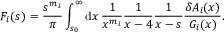<formula> <loc_0><loc_0><loc_500><loc_500>F _ { i } ( s ) = { \frac { s ^ { m _ { i } } } { \pi } } \int _ { s _ { 0 } } ^ { \infty } d x \, { \frac { 1 } { x ^ { m _ { i } } } } { \frac { 1 } { x - 4 } } { \frac { 1 } { x - s } } { \frac { \delta A _ { i } ( x ) } { G _ { i } ( x ) } } .</formula> 